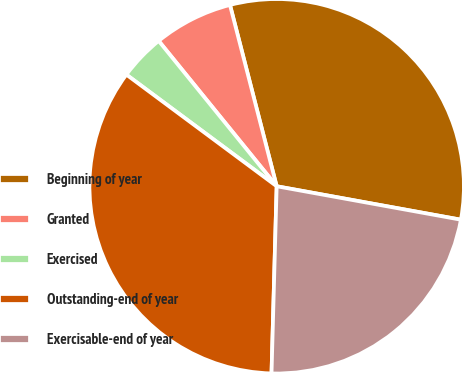Convert chart. <chart><loc_0><loc_0><loc_500><loc_500><pie_chart><fcel>Beginning of year<fcel>Granted<fcel>Exercised<fcel>Outstanding-end of year<fcel>Exercisable-end of year<nl><fcel>31.87%<fcel>6.84%<fcel>3.98%<fcel>34.73%<fcel>22.58%<nl></chart> 